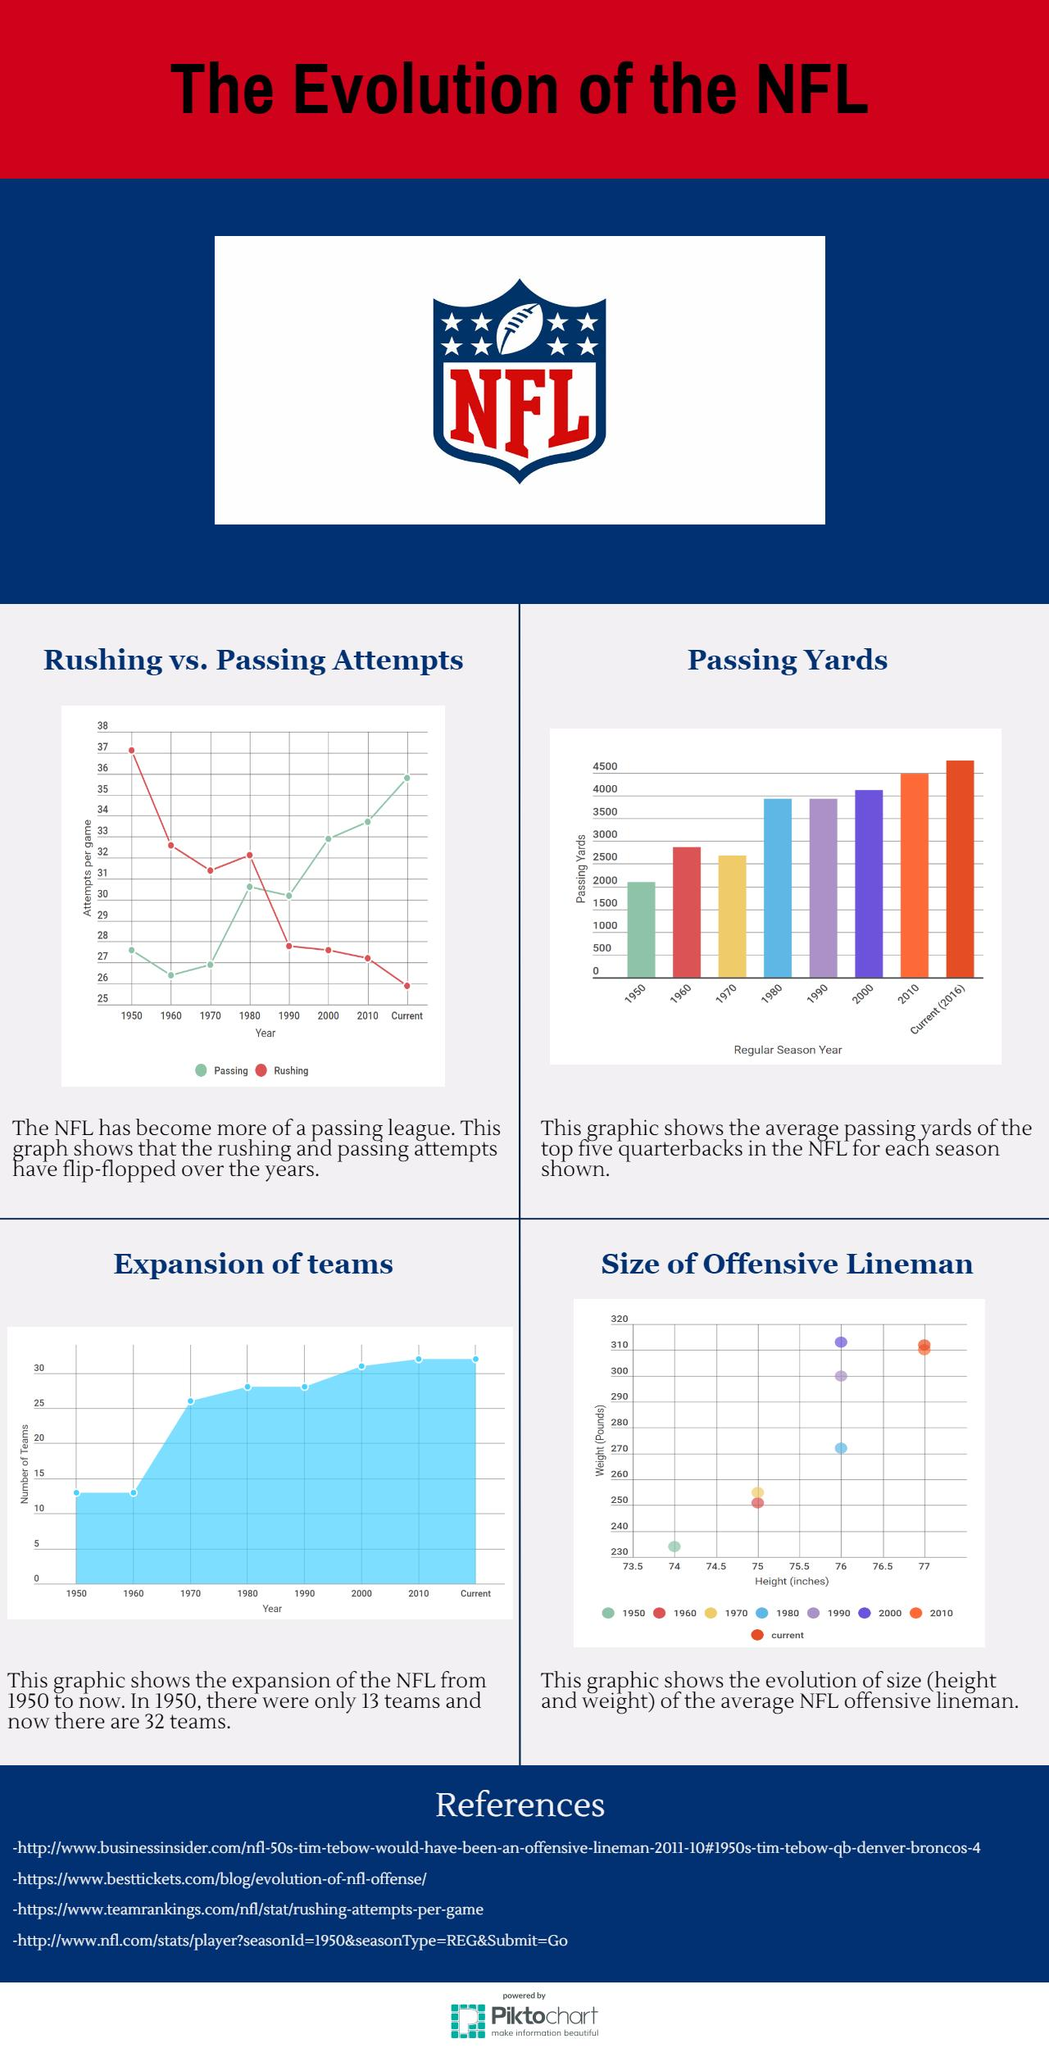Point out several critical features in this image. In 1950, the offensive line man recorded the lowest weight and height of any year. In 1990, the weight of linemen was 300 pounds. During the year 1970, the National Football League (NFL) consisted of 26 teams. The year with the second lowest number of passing attempts per game was 1970. The passing yards average in 1980 and 1990 was 3900. 